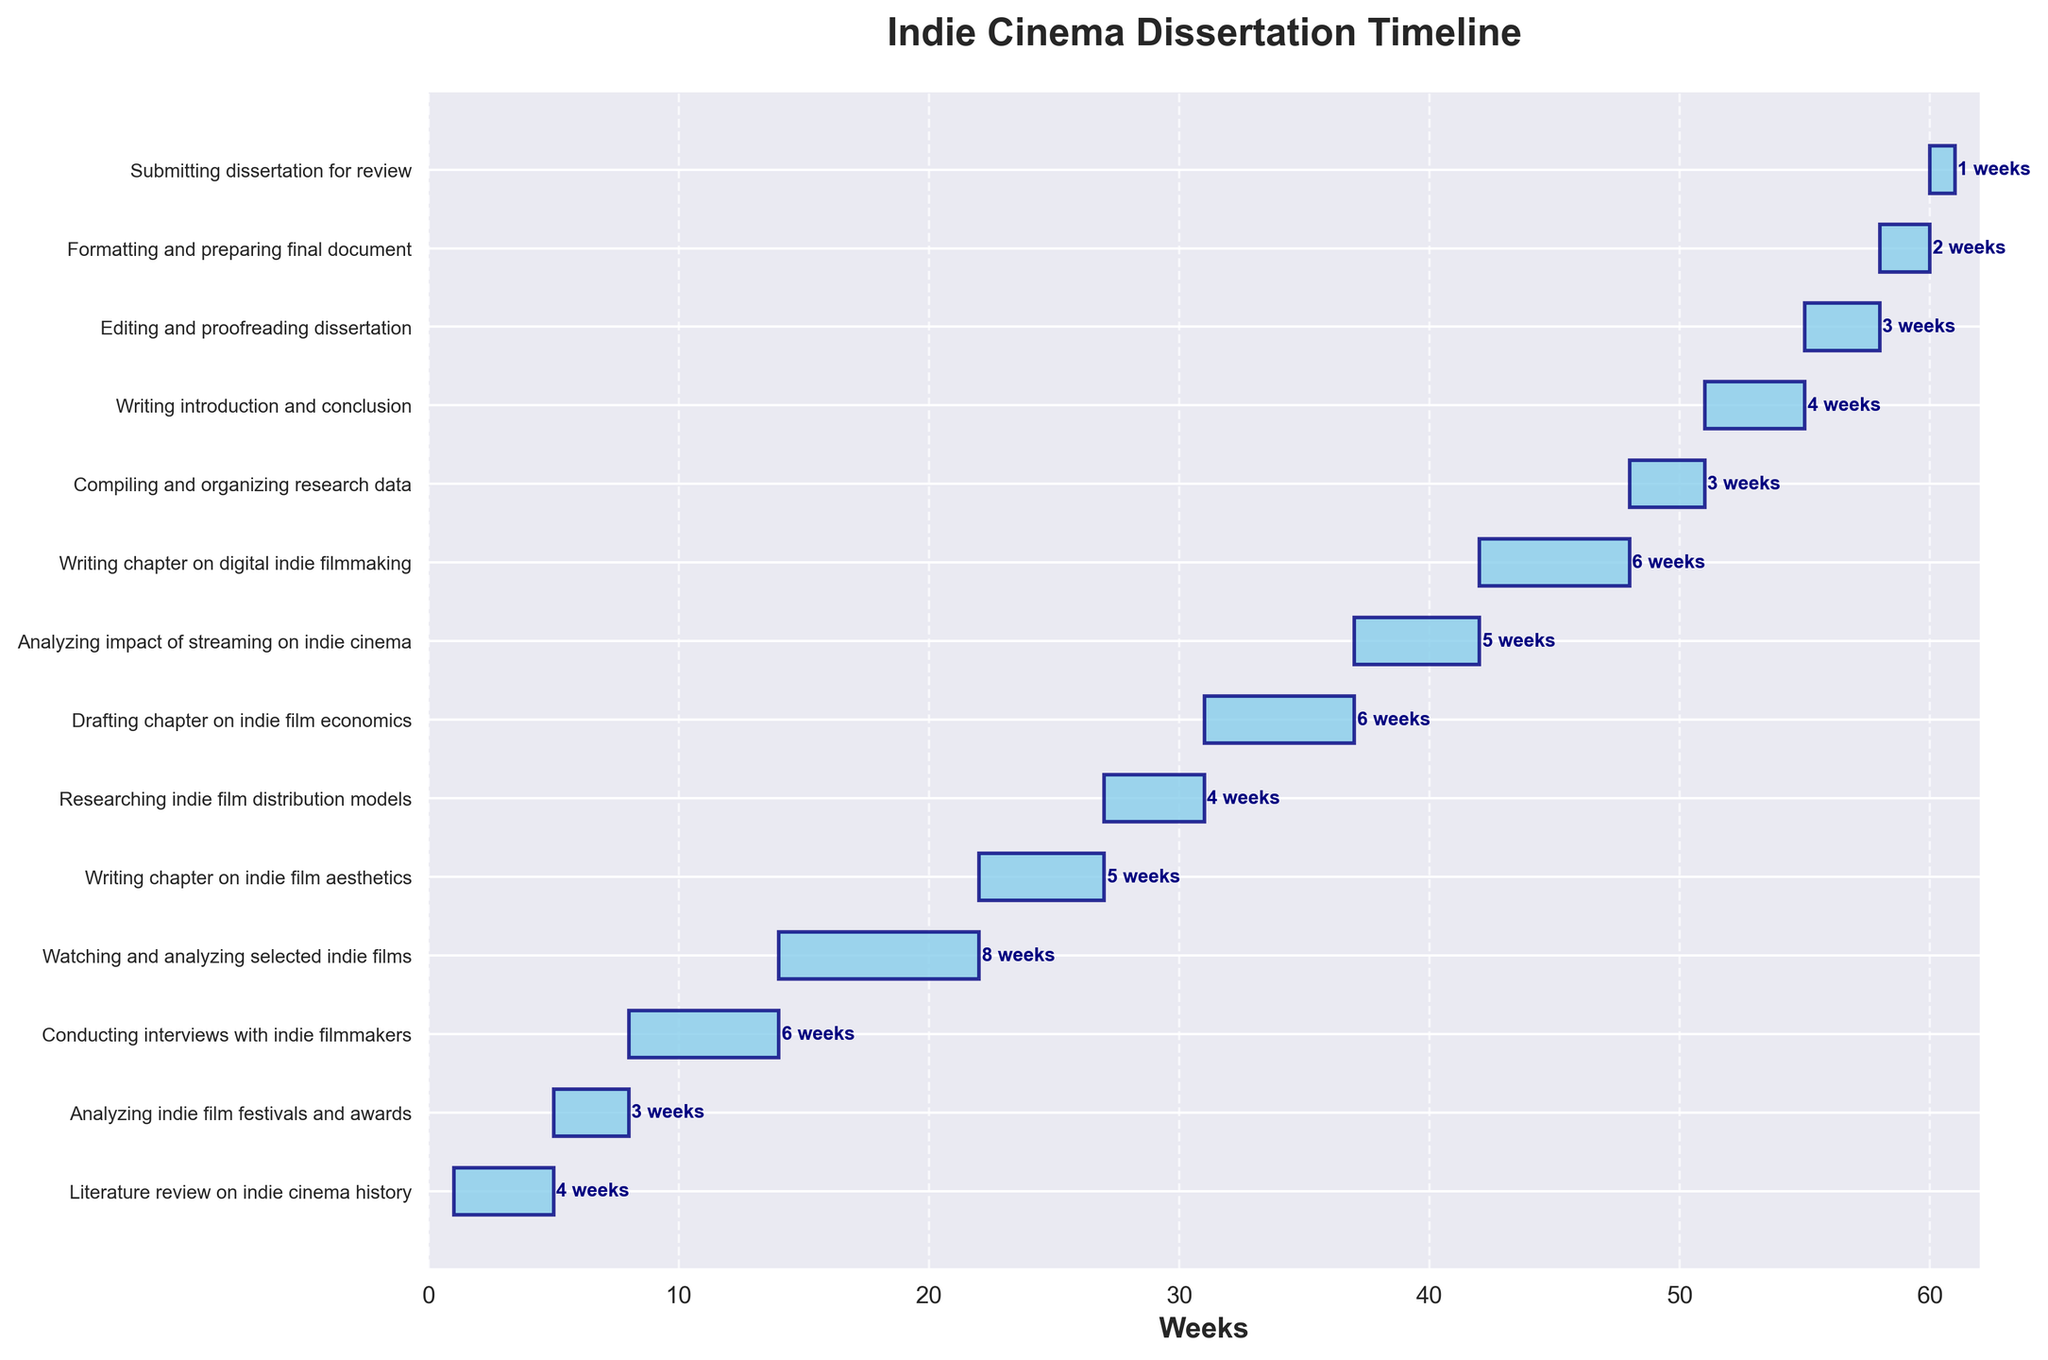What is the title of the Gantt Chart? The title is located at the top of the chart and is usually the largest text on the figure. It helps to understand what the chart represents.
Answer: Indie Cinema Dissertation Timeline What is the duration for "Watching and analyzing selected indie films"? Locate the task "Watching and analyzing selected indie films" on the y-axis and refer to the corresponding bar's label.
Answer: 8 weeks Which task has the shortest duration? Compare all the tasks' durations by looking at the length of each bar and finding the shortest one.
Answer: Submitting dissertation for review How many weeks in total does the dissertation project span? The project starts at week 1 and ends at week 61. Calculate the total by finding the difference between the start and end week.
Answer: 61 weeks What tasks start at week 5? Identify tasks that have a starting point at week 5 by looking at the left end of the bars.
Answer: Analyzing indie film festivals and awards What is the total combined duration of "Writing chapter on indie film aesthetics" and "Drafting chapter on indie film economics"? Add the durations of both tasks: "Writing chapter on indie film aesthetics" (5 weeks) + "Drafting chapter on indie film economics" (6 weeks).
Answer: 11 weeks Which task starts immediately after "Researching indie film distribution models"? Look for the task starting right after "Researching indie film distribution models", which ends at week 31.
Answer: Drafting chapter on indie film economics Comparing "Conducting interviews with indie filmmakers" and "Analyzing impact of streaming on indie cinema", which takes longer? Compare the durations of the two tasks: "Conducting interviews with indie filmmakers" (6 weeks) and "Analyzing impact of streaming on indie cinema" (5 weeks).
Answer: Conducting interviews with indie filmmakers How many tasks have a duration of 6 weeks? Count the number of bars with a duration label showing "6 weeks".
Answer: 3 tasks What is the last task mentioned, and when does it start? The last task is usually at the bottom of the list on the y-axis; find its starting point by looking at the left end of its bar.
Answer: Submitting dissertation for review, starts at week 60 